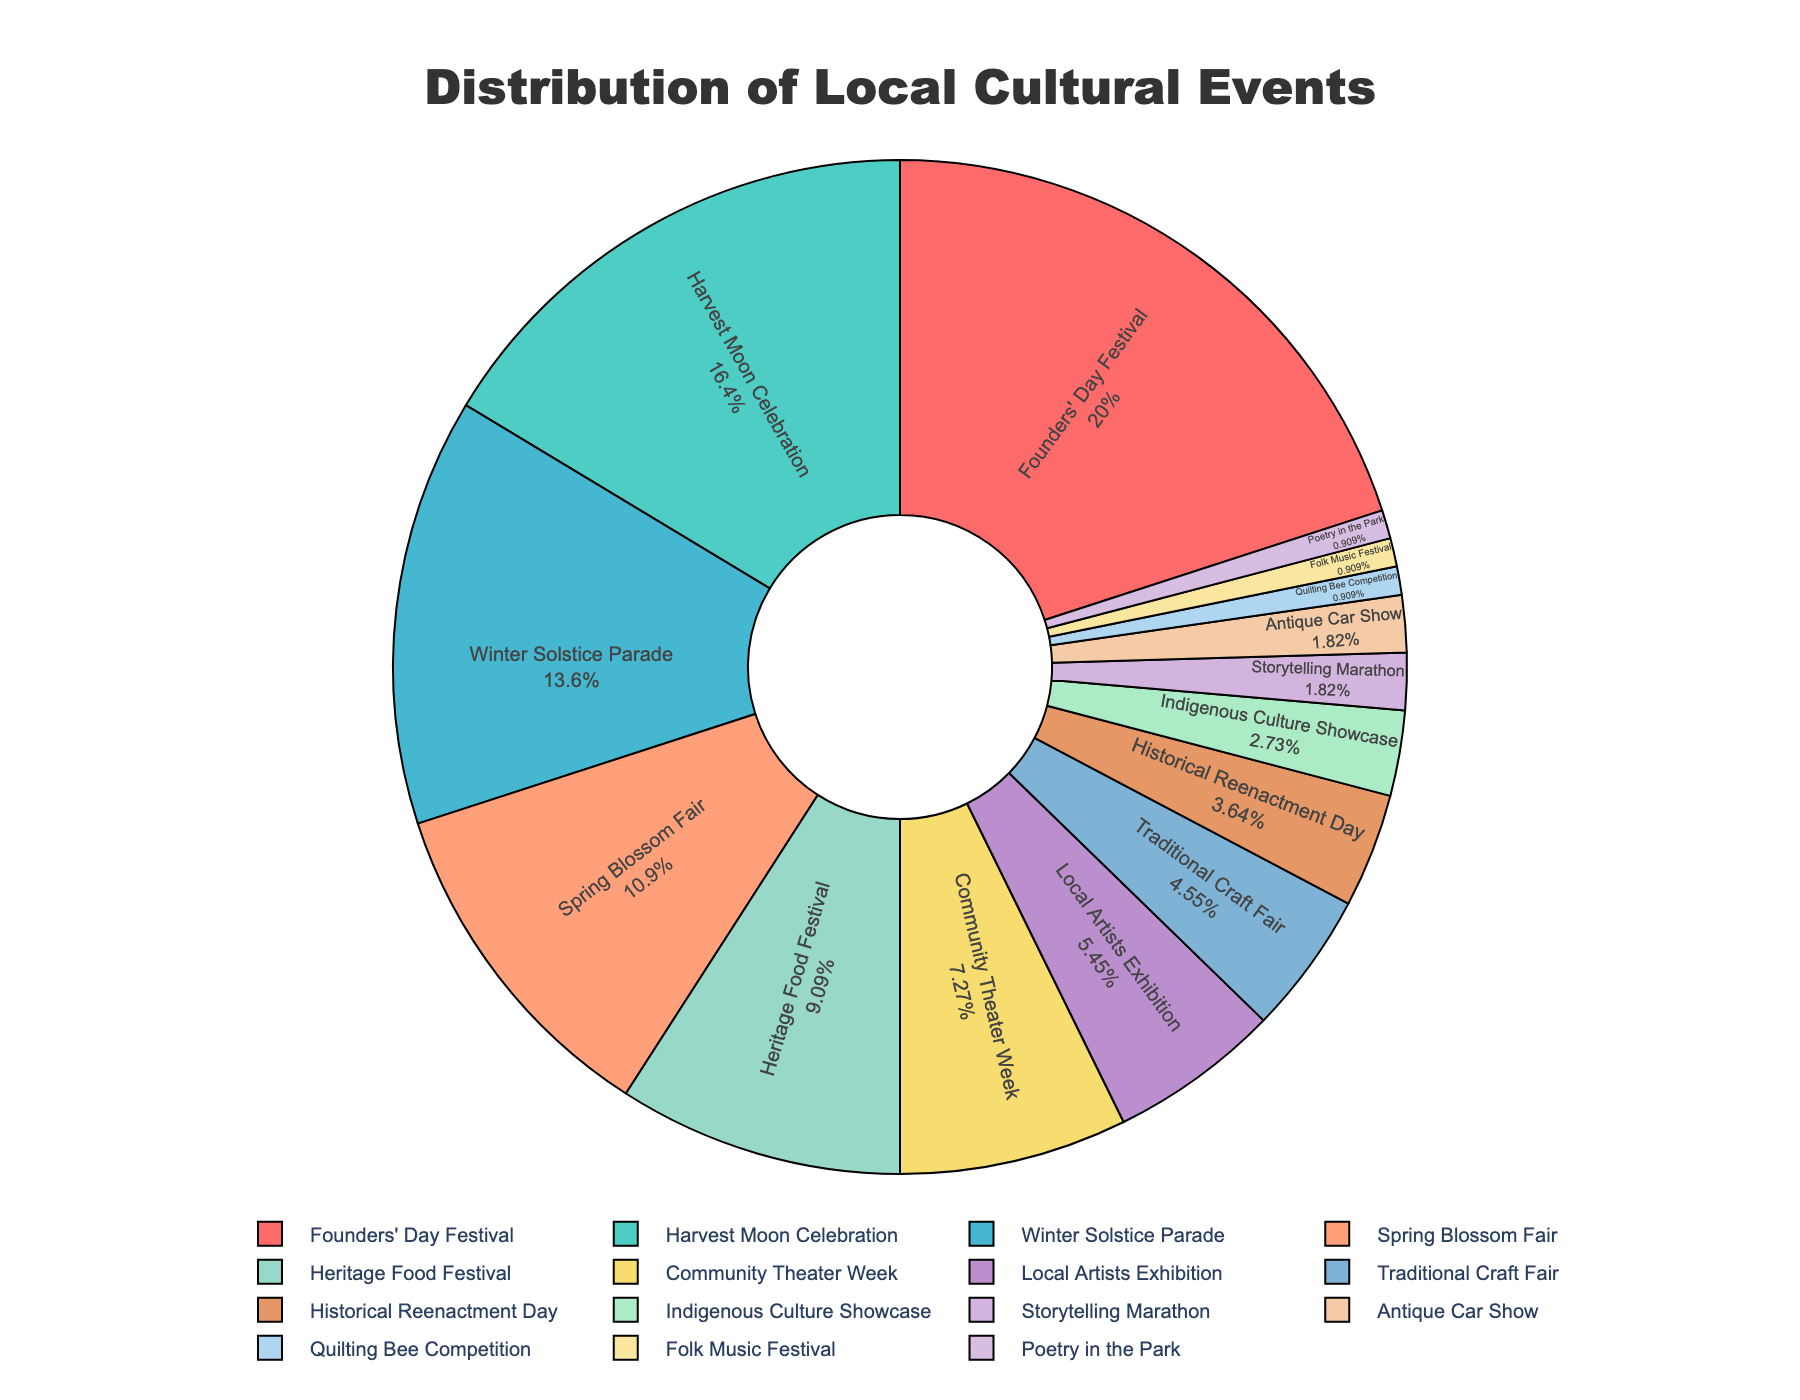What is the total percentage of the events that focus on traditional or historical themes? To find the total percentage of events focused on traditional or historical themes, we sum the percentages of the Harvest Moon Celebration (18%), Heritage Food Festival (10%), Traditional Craft Fair (5%), Historical Reenactment Day (4%), and Indigenous Culture Showcase (3%)
Answer: 40% Which event has the second highest percentage represented in the pie chart? The pie chart shows the percentages, with the second largest slice corresponding to the Harvest Moon Celebration at 18%
Answer: Harvest Moon Celebration What is the difference in percentage between Founders' Day Festival and Spring Blossom Fair? Founders' Day Festival has 22% and Spring Blossom Fair has 12%. Subtracting these gives: 22% - 12% = 10%
Answer: 10% Which category has more representation, Local Artists Exhibition or Community Theater Week? By comparing the slices, Community Theater Week is 8% and Local Artists Exhibition is 6%, thus Community Theater Week has more representation
Answer: Community Theater Week What is the combined percentage of the smallest three events depicted in the chart? The three smallest events are Quilting Bee Competition, Folk Music Festival, and Poetry in the Park with 1% each. Adding them together gives: 1% + 1% + 1% = 3%
Answer: 3% Which event represents a percentage closest to a quarter of the pie? 25% of the pie chart is closest to the Founders' Day Festival which is 22%
Answer: Founders' Day Festival What is the percentage difference between the Winter Solstice Parade and the Community Theater Week? Winter Solstice Parade represents 15% and Community Theater Week is 8%. The difference is: 15% - 8% = 7%
Answer: 7% How many events have a percentage of 5% or less? The events with ≤5% are Traditional Craft Fair (5%), Historical Reenactment Day (4%), Indigenous Culture Showcase (3%), Storytelling Marathon (2%), Antique Car Show (2%), Quilting Bee Competition (1%), Folk Music Festival (1%), and Poetry in the Park (1%) totaling 8 events
Answer: 8 What colors are used to represent the Founders' Day Festival and the Harvest Moon Celebration? The Founders' Day Festival is represented by red, and the Harvest Moon Celebration by teal in the pie chart
Answer: red, teal What is the combined percentage of the top three events in the chart? Adding the percentages of the Founders' Day Festival (22%), Harvest Moon Celebration (18%), and Winter Solstice Parade (15%) gives: 22% + 18% + 15% = 55%
Answer: 55% 